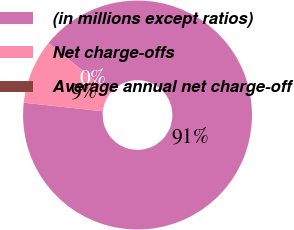<chart> <loc_0><loc_0><loc_500><loc_500><pie_chart><fcel>(in millions except ratios)<fcel>Net charge-offs<fcel>Average annual net charge-off<nl><fcel>90.91%<fcel>9.09%<fcel>0.0%<nl></chart> 